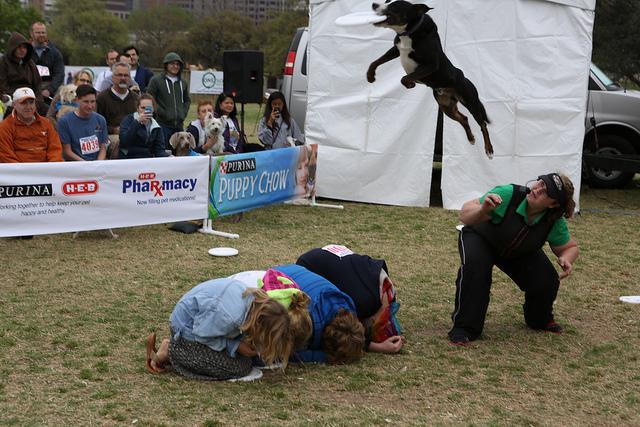Where is this event taking place?
Quick response, please. Dog show. Is there a crowd?
Concise answer only. Yes. How many people is this dog jumping?
Write a very short answer. 5. 